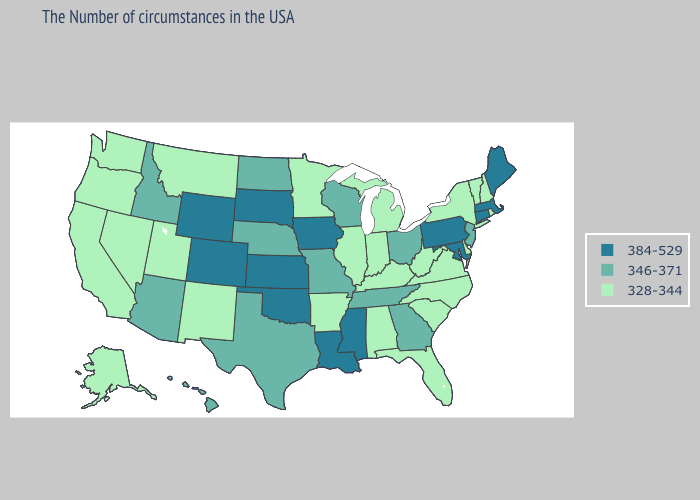Does Mississippi have the same value as New Hampshire?
Write a very short answer. No. What is the value of Missouri?
Concise answer only. 346-371. Name the states that have a value in the range 346-371?
Give a very brief answer. New Jersey, Ohio, Georgia, Tennessee, Wisconsin, Missouri, Nebraska, Texas, North Dakota, Arizona, Idaho, Hawaii. Which states hav the highest value in the MidWest?
Keep it brief. Iowa, Kansas, South Dakota. Does Colorado have the highest value in the West?
Answer briefly. Yes. Name the states that have a value in the range 346-371?
Quick response, please. New Jersey, Ohio, Georgia, Tennessee, Wisconsin, Missouri, Nebraska, Texas, North Dakota, Arizona, Idaho, Hawaii. Name the states that have a value in the range 328-344?
Concise answer only. Rhode Island, New Hampshire, Vermont, New York, Delaware, Virginia, North Carolina, South Carolina, West Virginia, Florida, Michigan, Kentucky, Indiana, Alabama, Illinois, Arkansas, Minnesota, New Mexico, Utah, Montana, Nevada, California, Washington, Oregon, Alaska. Among the states that border Oregon , which have the highest value?
Give a very brief answer. Idaho. Does Indiana have a lower value than Delaware?
Be succinct. No. Name the states that have a value in the range 328-344?
Keep it brief. Rhode Island, New Hampshire, Vermont, New York, Delaware, Virginia, North Carolina, South Carolina, West Virginia, Florida, Michigan, Kentucky, Indiana, Alabama, Illinois, Arkansas, Minnesota, New Mexico, Utah, Montana, Nevada, California, Washington, Oregon, Alaska. What is the highest value in the West ?
Keep it brief. 384-529. Name the states that have a value in the range 346-371?
Keep it brief. New Jersey, Ohio, Georgia, Tennessee, Wisconsin, Missouri, Nebraska, Texas, North Dakota, Arizona, Idaho, Hawaii. What is the value of New Jersey?
Keep it brief. 346-371. 